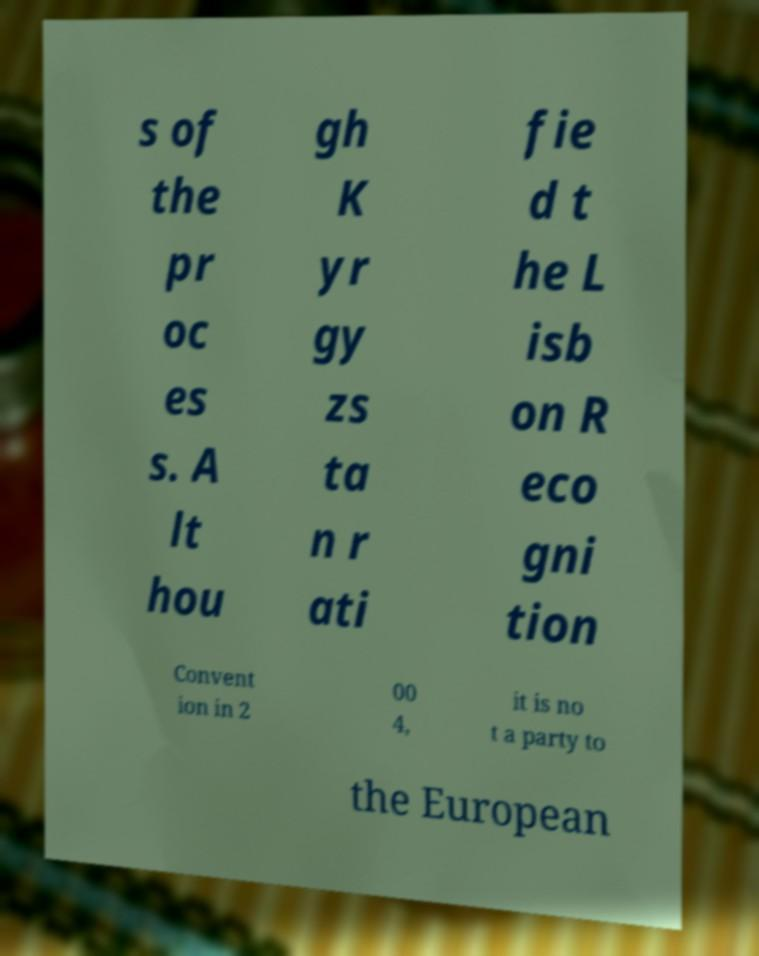For documentation purposes, I need the text within this image transcribed. Could you provide that? s of the pr oc es s. A lt hou gh K yr gy zs ta n r ati fie d t he L isb on R eco gni tion Convent ion in 2 00 4, it is no t a party to the European 